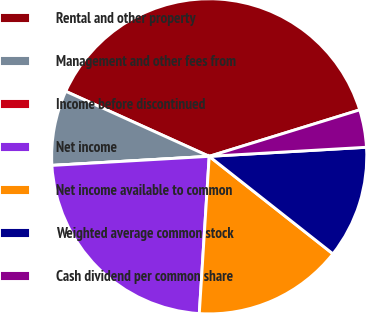<chart> <loc_0><loc_0><loc_500><loc_500><pie_chart><fcel>Rental and other property<fcel>Management and other fees from<fcel>Income before discontinued<fcel>Net income<fcel>Net income available to common<fcel>Weighted average common stock<fcel>Cash dividend per common share<nl><fcel>38.46%<fcel>7.69%<fcel>0.0%<fcel>23.08%<fcel>15.38%<fcel>11.54%<fcel>3.85%<nl></chart> 